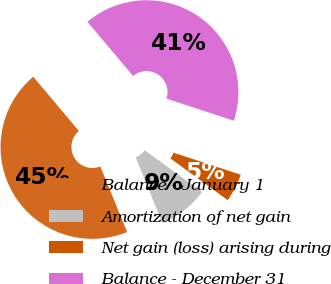Convert chart. <chart><loc_0><loc_0><loc_500><loc_500><pie_chart><fcel>Balance - January 1<fcel>Amortization of net gain<fcel>Net gain (loss) arising during<fcel>Balance - December 31<nl><fcel>45.04%<fcel>8.82%<fcel>4.96%<fcel>41.18%<nl></chart> 